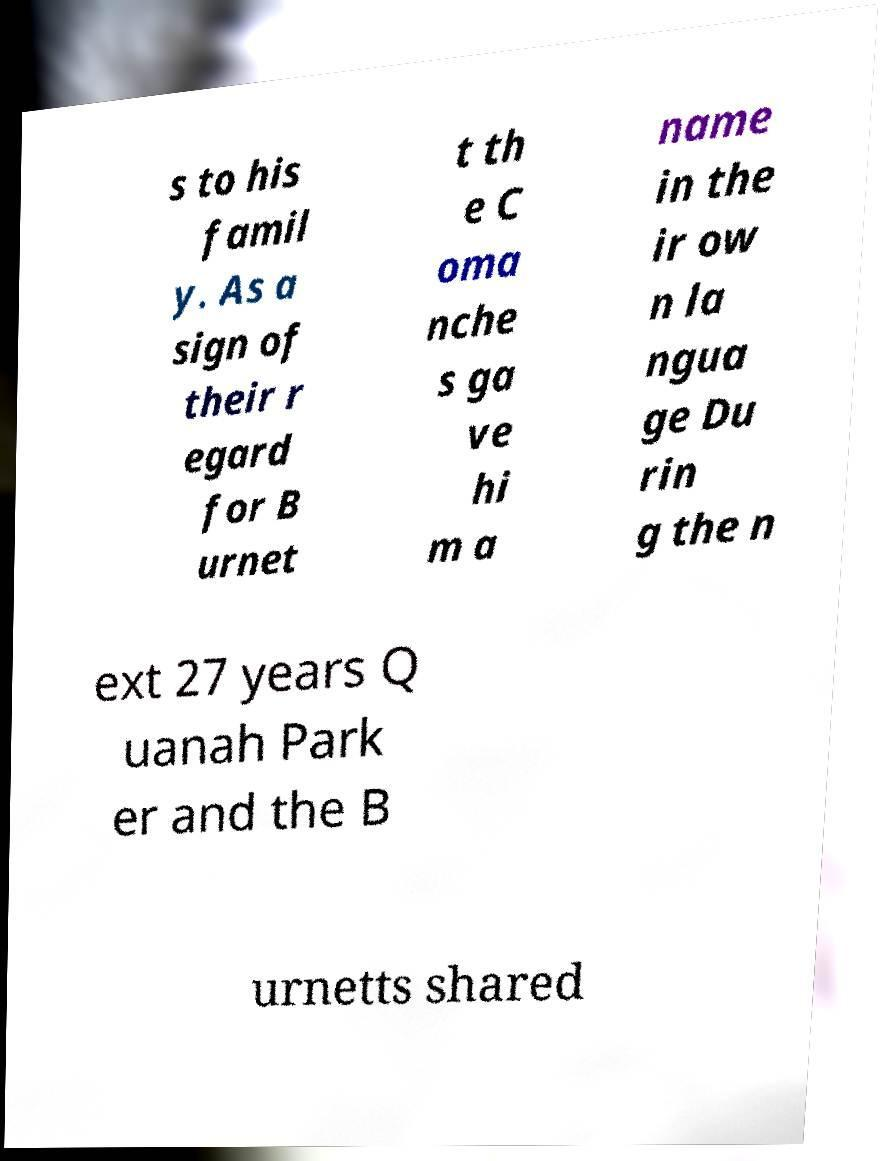Can you accurately transcribe the text from the provided image for me? s to his famil y. As a sign of their r egard for B urnet t th e C oma nche s ga ve hi m a name in the ir ow n la ngua ge Du rin g the n ext 27 years Q uanah Park er and the B urnetts shared 